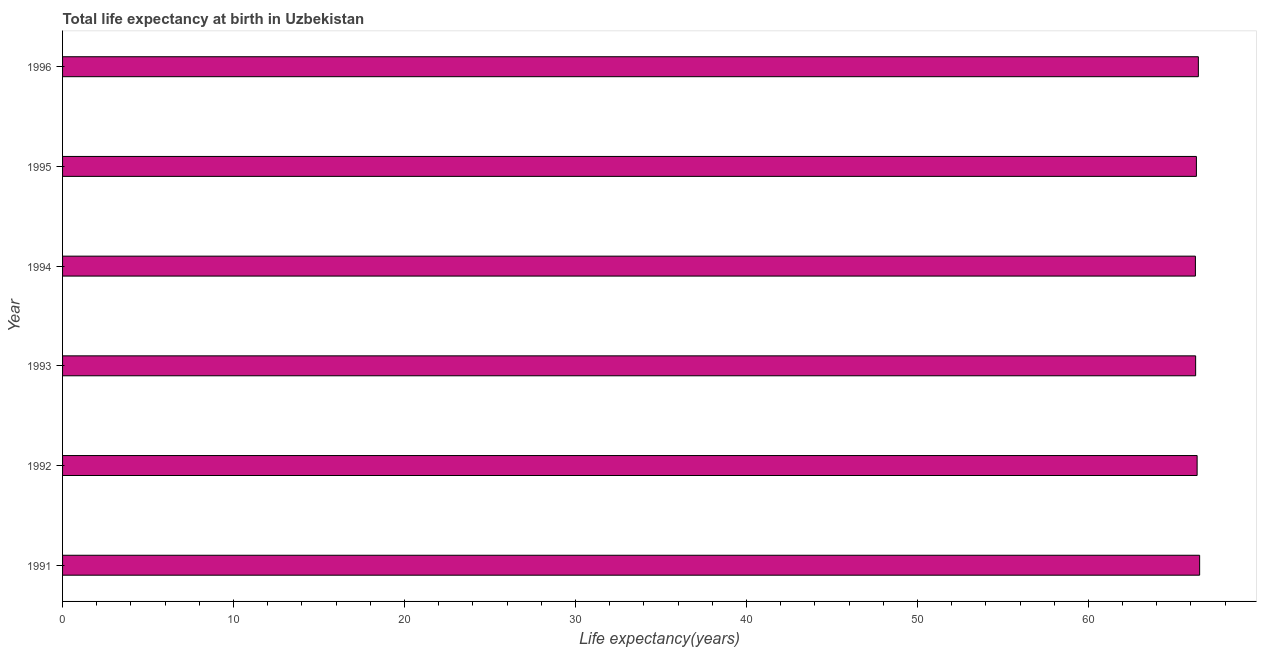Does the graph contain grids?
Make the answer very short. No. What is the title of the graph?
Provide a short and direct response. Total life expectancy at birth in Uzbekistan. What is the label or title of the X-axis?
Provide a succinct answer. Life expectancy(years). What is the label or title of the Y-axis?
Offer a terse response. Year. What is the life expectancy at birth in 1995?
Your response must be concise. 66.32. Across all years, what is the maximum life expectancy at birth?
Your response must be concise. 66.51. Across all years, what is the minimum life expectancy at birth?
Make the answer very short. 66.26. What is the sum of the life expectancy at birth?
Your answer should be very brief. 398.15. What is the difference between the life expectancy at birth in 1991 and 1996?
Make the answer very short. 0.07. What is the average life expectancy at birth per year?
Make the answer very short. 66.36. What is the median life expectancy at birth?
Offer a very short reply. 66.34. In how many years, is the life expectancy at birth greater than 6 years?
Offer a terse response. 6. Do a majority of the years between 1995 and 1994 (inclusive) have life expectancy at birth greater than 34 years?
Offer a very short reply. No. Is the difference between the life expectancy at birth in 1993 and 1995 greater than the difference between any two years?
Give a very brief answer. No. What is the difference between the highest and the second highest life expectancy at birth?
Your answer should be compact. 0.07. What is the difference between the highest and the lowest life expectancy at birth?
Offer a very short reply. 0.25. In how many years, is the life expectancy at birth greater than the average life expectancy at birth taken over all years?
Make the answer very short. 3. How many years are there in the graph?
Provide a short and direct response. 6. Are the values on the major ticks of X-axis written in scientific E-notation?
Keep it short and to the point. No. What is the Life expectancy(years) in 1991?
Provide a short and direct response. 66.51. What is the Life expectancy(years) of 1992?
Make the answer very short. 66.36. What is the Life expectancy(years) in 1993?
Offer a terse response. 66.27. What is the Life expectancy(years) of 1994?
Your answer should be compact. 66.26. What is the Life expectancy(years) in 1995?
Provide a succinct answer. 66.32. What is the Life expectancy(years) in 1996?
Your answer should be compact. 66.43. What is the difference between the Life expectancy(years) in 1991 and 1992?
Your response must be concise. 0.15. What is the difference between the Life expectancy(years) in 1991 and 1993?
Make the answer very short. 0.23. What is the difference between the Life expectancy(years) in 1991 and 1994?
Your answer should be compact. 0.25. What is the difference between the Life expectancy(years) in 1991 and 1995?
Give a very brief answer. 0.19. What is the difference between the Life expectancy(years) in 1991 and 1996?
Your answer should be compact. 0.07. What is the difference between the Life expectancy(years) in 1992 and 1993?
Keep it short and to the point. 0.09. What is the difference between the Life expectancy(years) in 1992 and 1994?
Offer a very short reply. 0.1. What is the difference between the Life expectancy(years) in 1992 and 1995?
Your response must be concise. 0.04. What is the difference between the Life expectancy(years) in 1992 and 1996?
Provide a succinct answer. -0.07. What is the difference between the Life expectancy(years) in 1993 and 1994?
Give a very brief answer. 0.01. What is the difference between the Life expectancy(years) in 1993 and 1995?
Offer a very short reply. -0.04. What is the difference between the Life expectancy(years) in 1993 and 1996?
Your answer should be compact. -0.16. What is the difference between the Life expectancy(years) in 1994 and 1995?
Make the answer very short. -0.06. What is the difference between the Life expectancy(years) in 1994 and 1996?
Provide a short and direct response. -0.17. What is the difference between the Life expectancy(years) in 1995 and 1996?
Provide a succinct answer. -0.11. What is the ratio of the Life expectancy(years) in 1991 to that in 1992?
Your answer should be very brief. 1. What is the ratio of the Life expectancy(years) in 1991 to that in 1994?
Offer a very short reply. 1. What is the ratio of the Life expectancy(years) in 1991 to that in 1996?
Make the answer very short. 1. What is the ratio of the Life expectancy(years) in 1992 to that in 1996?
Make the answer very short. 1. What is the ratio of the Life expectancy(years) in 1993 to that in 1994?
Your response must be concise. 1. What is the ratio of the Life expectancy(years) in 1993 to that in 1995?
Your answer should be compact. 1. What is the ratio of the Life expectancy(years) in 1994 to that in 1996?
Make the answer very short. 1. What is the ratio of the Life expectancy(years) in 1995 to that in 1996?
Provide a short and direct response. 1. 